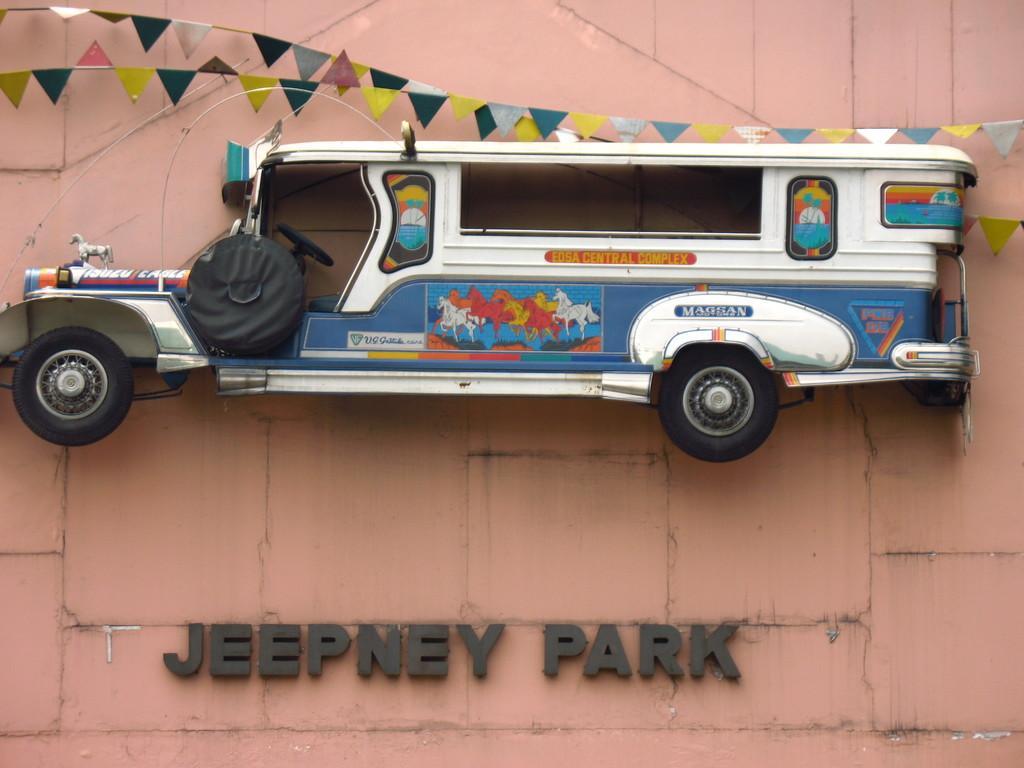Could you give a brief overview of what you see in this image? As we can see in the image there is a wall and toy car. 